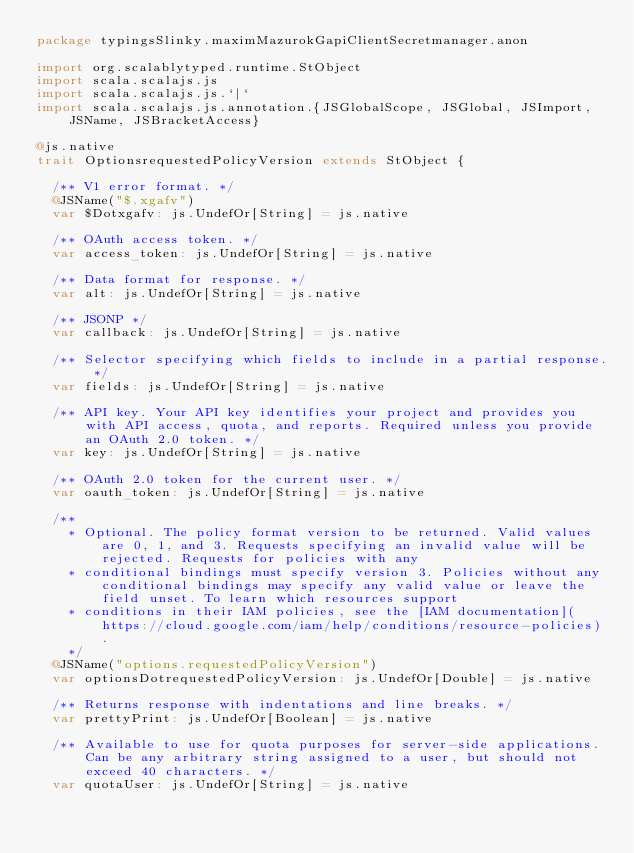<code> <loc_0><loc_0><loc_500><loc_500><_Scala_>package typingsSlinky.maximMazurokGapiClientSecretmanager.anon

import org.scalablytyped.runtime.StObject
import scala.scalajs.js
import scala.scalajs.js.`|`
import scala.scalajs.js.annotation.{JSGlobalScope, JSGlobal, JSImport, JSName, JSBracketAccess}

@js.native
trait OptionsrequestedPolicyVersion extends StObject {
  
  /** V1 error format. */
  @JSName("$.xgafv")
  var $Dotxgafv: js.UndefOr[String] = js.native
  
  /** OAuth access token. */
  var access_token: js.UndefOr[String] = js.native
  
  /** Data format for response. */
  var alt: js.UndefOr[String] = js.native
  
  /** JSONP */
  var callback: js.UndefOr[String] = js.native
  
  /** Selector specifying which fields to include in a partial response. */
  var fields: js.UndefOr[String] = js.native
  
  /** API key. Your API key identifies your project and provides you with API access, quota, and reports. Required unless you provide an OAuth 2.0 token. */
  var key: js.UndefOr[String] = js.native
  
  /** OAuth 2.0 token for the current user. */
  var oauth_token: js.UndefOr[String] = js.native
  
  /**
    * Optional. The policy format version to be returned. Valid values are 0, 1, and 3. Requests specifying an invalid value will be rejected. Requests for policies with any
    * conditional bindings must specify version 3. Policies without any conditional bindings may specify any valid value or leave the field unset. To learn which resources support
    * conditions in their IAM policies, see the [IAM documentation](https://cloud.google.com/iam/help/conditions/resource-policies).
    */
  @JSName("options.requestedPolicyVersion")
  var optionsDotrequestedPolicyVersion: js.UndefOr[Double] = js.native
  
  /** Returns response with indentations and line breaks. */
  var prettyPrint: js.UndefOr[Boolean] = js.native
  
  /** Available to use for quota purposes for server-side applications. Can be any arbitrary string assigned to a user, but should not exceed 40 characters. */
  var quotaUser: js.UndefOr[String] = js.native
  </code> 